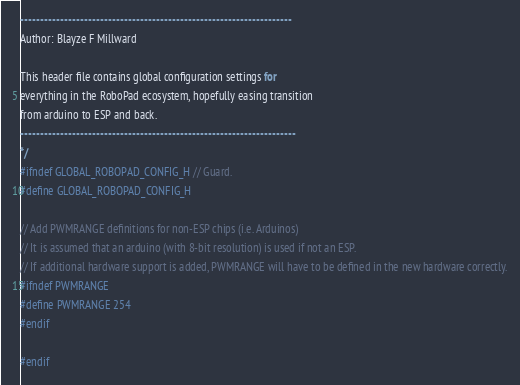<code> <loc_0><loc_0><loc_500><loc_500><_C_>--------------------------------------------------------------------
Author: Blayze F Millward

This header file contains global configuration settings for
everything in the RoboPad ecosystem, hopefully easing transition
from arduino to ESP and back.
---------------------------------------------------------------------
*/
#ifndef GLOBAL_ROBOPAD_CONFIG_H // Guard.
#define GLOBAL_ROBOPAD_CONFIG_H

// Add PWMRANGE definitions for non-ESP chips (i.e. Arduinos)
// It is assumed that an arduino (with 8-bit resolution) is used if not an ESP.
// If additional hardware support is added, PWMRANGE will have to be defined in the new hardware correctly.
#ifndef PWMRANGE
#define PWMRANGE 254
#endif

#endif
</code> 